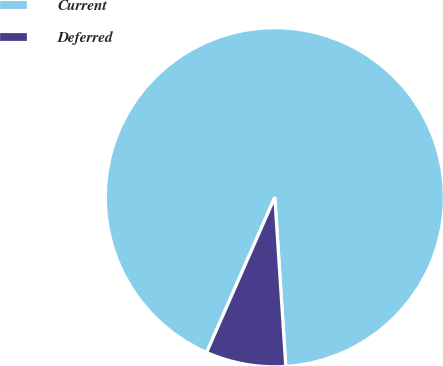Convert chart to OTSL. <chart><loc_0><loc_0><loc_500><loc_500><pie_chart><fcel>Current<fcel>Deferred<nl><fcel>92.38%<fcel>7.62%<nl></chart> 